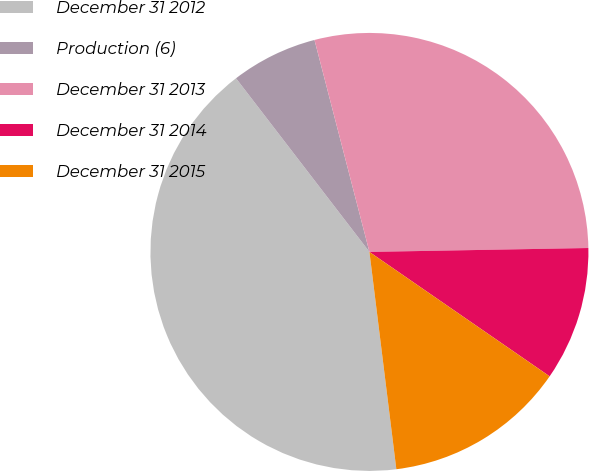Convert chart. <chart><loc_0><loc_0><loc_500><loc_500><pie_chart><fcel>December 31 2012<fcel>Production (6)<fcel>December 31 2013<fcel>December 31 2014<fcel>December 31 2015<nl><fcel>41.53%<fcel>6.39%<fcel>28.75%<fcel>9.9%<fcel>13.42%<nl></chart> 